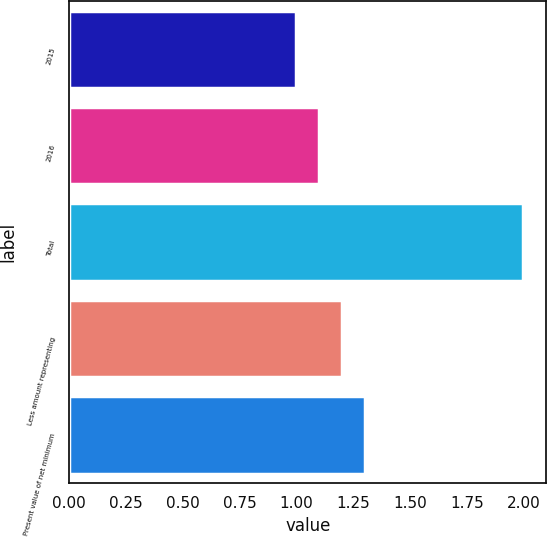Convert chart to OTSL. <chart><loc_0><loc_0><loc_500><loc_500><bar_chart><fcel>2015<fcel>2016<fcel>Total<fcel>Less amount representing<fcel>Present value of net minimum<nl><fcel>1<fcel>1.1<fcel>2<fcel>1.2<fcel>1.3<nl></chart> 